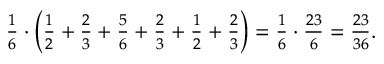Convert formula to latex. <formula><loc_0><loc_0><loc_500><loc_500>\begin{array} { r } { \frac { 1 } { 6 } \cdot \left ( \frac { 1 } { 2 } + \frac { 2 } { 3 } + \frac { 5 } { 6 } + \frac { 2 } { 3 } + \frac { 1 } { 2 } + \frac { 2 } { 3 } \right ) = \frac { 1 } { 6 } \cdot \frac { 2 3 } { 6 } = \frac { 2 3 } { 3 6 } . } \end{array}</formula> 